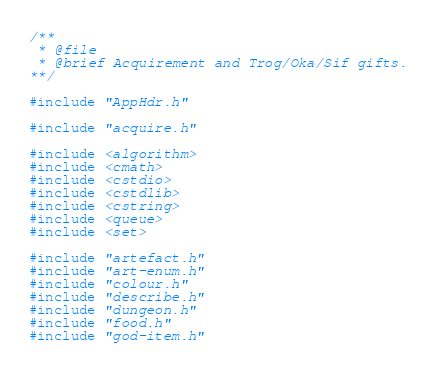Convert code to text. <code><loc_0><loc_0><loc_500><loc_500><_C++_>/**
 * @file
 * @brief Acquirement and Trog/Oka/Sif gifts.
**/

#include "AppHdr.h"

#include "acquire.h"

#include <algorithm>
#include <cmath>
#include <cstdio>
#include <cstdlib>
#include <cstring>
#include <queue>
#include <set>

#include "artefact.h"
#include "art-enum.h"
#include "colour.h"
#include "describe.h"
#include "dungeon.h"
#include "food.h"
#include "god-item.h"</code> 